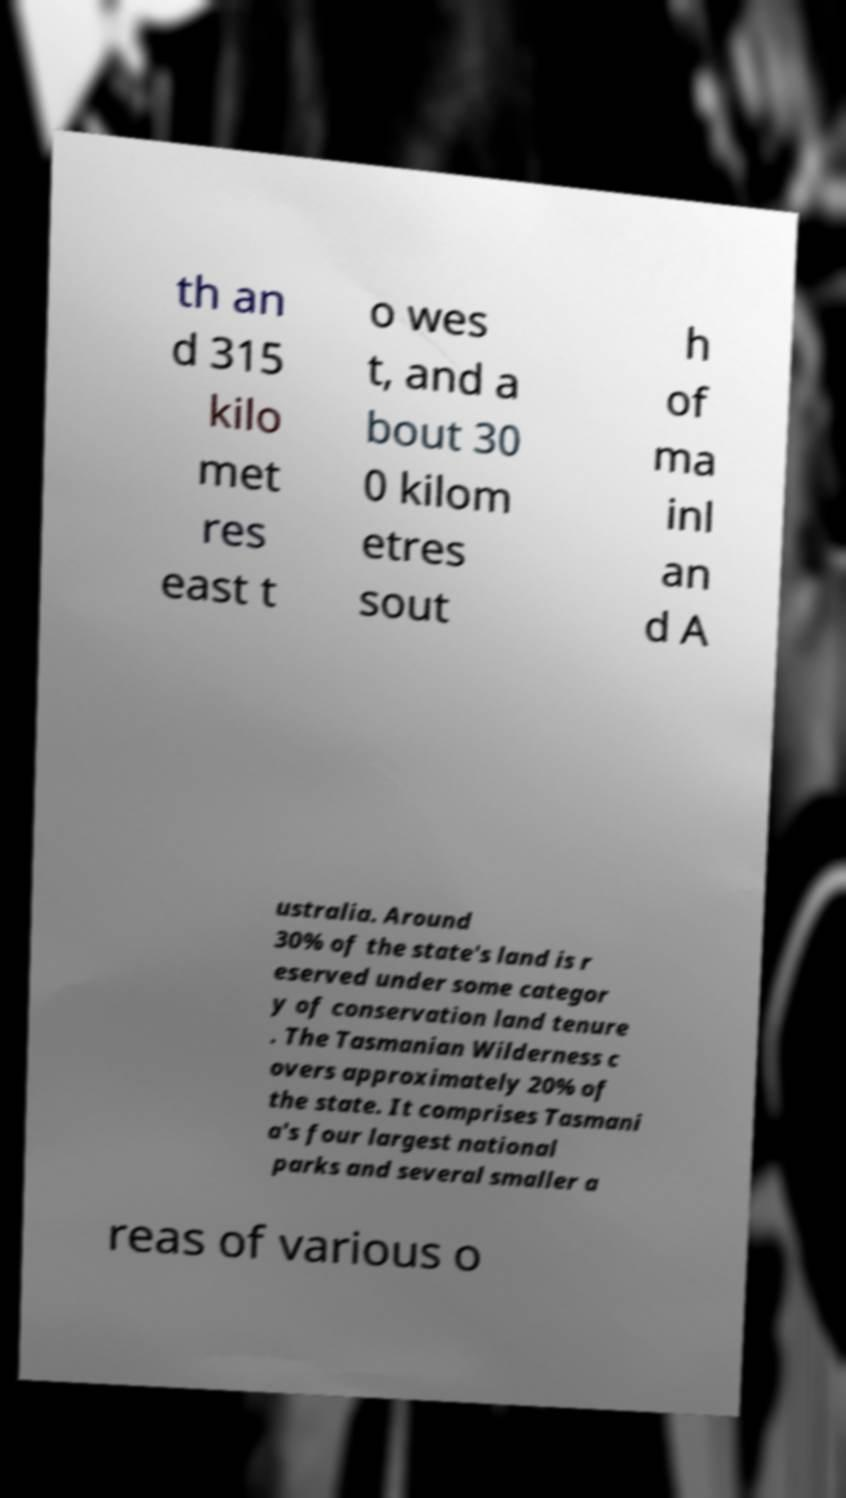There's text embedded in this image that I need extracted. Can you transcribe it verbatim? th an d 315 kilo met res east t o wes t, and a bout 30 0 kilom etres sout h of ma inl an d A ustralia. Around 30% of the state's land is r eserved under some categor y of conservation land tenure . The Tasmanian Wilderness c overs approximately 20% of the state. It comprises Tasmani a's four largest national parks and several smaller a reas of various o 